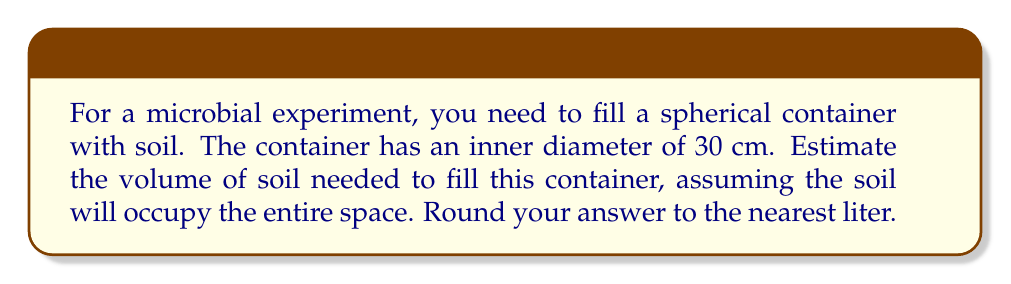Teach me how to tackle this problem. To solve this problem, we'll follow these steps:

1. Identify the formula for the volume of a sphere:
   $$V = \frac{4}{3}\pi r^3$$
   where $V$ is the volume and $r$ is the radius.

2. Calculate the radius:
   The diameter is 30 cm, so the radius is half of that:
   $$r = \frac{30}{2} = 15 \text{ cm}$$

3. Substitute the radius into the volume formula:
   $$V = \frac{4}{3}\pi (15)^3$$

4. Calculate the volume:
   $$V = \frac{4}{3}\pi (3375)$$
   $$V = 4500\pi \text{ cm}^3$$
   $$V \approx 14137.17 \text{ cm}^3$$

5. Convert cubic centimeters to liters:
   1 liter = 1000 cm³
   $$14137.17 \text{ cm}^3 = 14.13717 \text{ liters}$$

6. Round to the nearest liter:
   14.13717 liters rounds to 14 liters.

Therefore, you need approximately 14 liters of soil to fill the spherical container.
Answer: 14 liters 